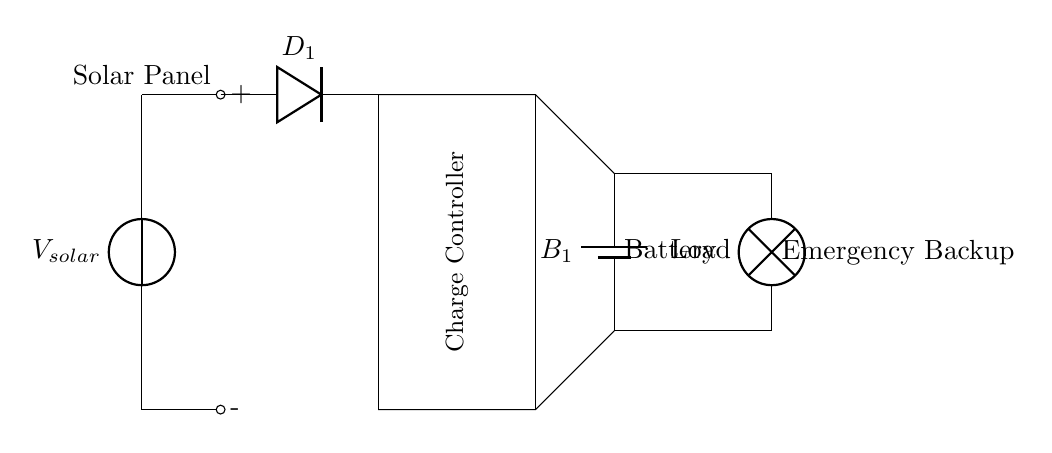What is the type of power source in this circuit? The power source is a solar panel, which is indicated at the left side of the circuit as "Solar Panel."
Answer: Solar panel What is the purpose of the diode in this circuit? The diode allows current to flow in only one direction, preventing the battery from discharging back into the solar panel. This is a critical function for battery protection.
Answer: Prevents reverse current What component regulates the charging of the battery? The charge controller manages the voltage and current coming from the solar panel to safely charge the battery, which is a key component shown in the rectangular block labeled "Charge Controller."
Answer: Charge controller How many batteries are used in this circuit? There is one battery in the circuit, which is labeled as "B1" next to the battery symbol, indicating a single battery configuration.
Answer: One battery What is the load connected to the battery? The load is a lamp, specified in the circuit as "Load," which indicates what device is drawing power from the battery when needed.
Answer: Lamp What is the output voltage of the solar panel indicated in the circuit? Although the specific voltage value is not provided in the diagram, by standard practice, solar panels can vary widely; thus, without additional information, we cannot determine a fixed voltage. In general scenarios, solar panel voltages can range typically from 12 to 24 volts.
Answer: Not specified What does the arrow on the diode represent? The arrow on the diode symbol indicates the direction of conventional current flow, showing that it allows current to flow from the anode to cathode while blocking reverse flow, which is essential for ensuring proper function within the circuit.
Answer: Direction of current flow 